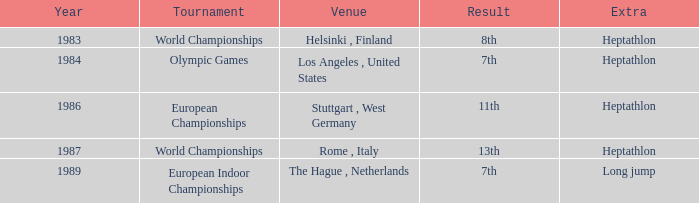In which city were the 1984 olympics held? Olympic Games. 